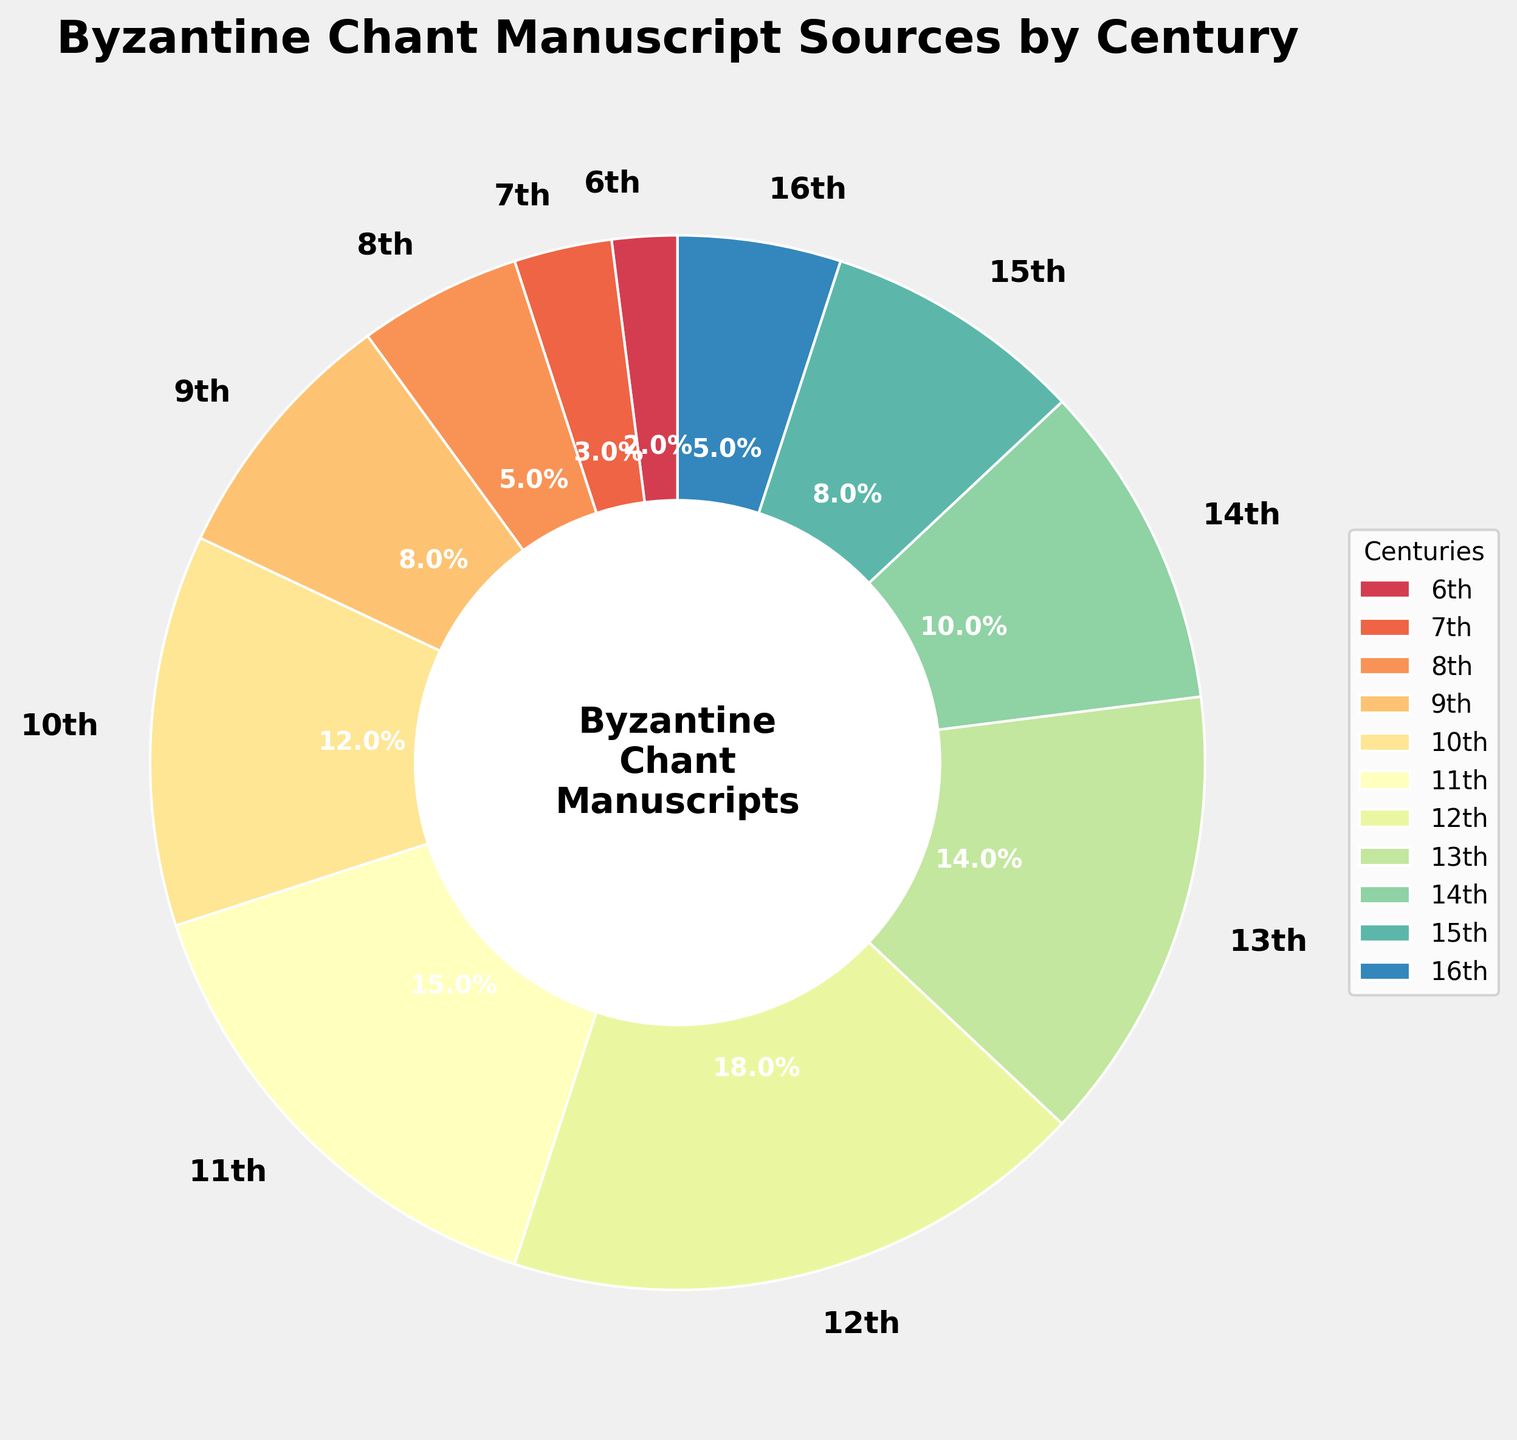What percentage of Byzantine Chant manuscripts were created during the 11th century? Locate the 11th century segment in the pie chart and read the percentage label.
Answer: 15% Which century had the highest percentage of Byzantine Chant manuscripts? Identify the segment with the largest size and percentage label in the pie chart.
Answer: 12th Compare the percentage of manuscripts from the 6th and 10th centuries. Which century had a higher percentage? Find the segments for the 6th and 10th centuries and compare the percentage labels. The 10th century has 12%, while the 6th century has 2%.
Answer: 10th What is the combined percentage of manuscripts from the 9th and 15th centuries? Add the percentages of the 9th and 15th centuries: 8% + 8% = 16%.
Answer: 16% Which two consecutive centuries show the largest increase in the percentage of manuscripts? Calculate the differences between the percentages of all consecutive centuries and identify the largest difference: (10th-9th) = 4%, (11th-10th) = 3%, (12th-11th) = 3%.
Answer: 9th to 10th What is the median percentage value of the manuscript sources by century? Arrange the percentages in ascending order and find the median (middle value) of the sequence: 2%, 3%, 5%, 5%, 8%, 8%, 10%, 12%, 14%, 15%, 18%. The median is 10%.
Answer: 10% Which century had roughly one-fifth of the total manuscript sources? Identify the century whose percentage is closest to 20%. The 12th century has 18%, which is close to one-fifth (20%).
Answer: 12th What is the difference between the percentage of manuscripts from the 13th and 8th centuries? Identify and subtract the percentages for the 8th and 13th centuries: 14% - 5% = 9%.
Answer: 9% 